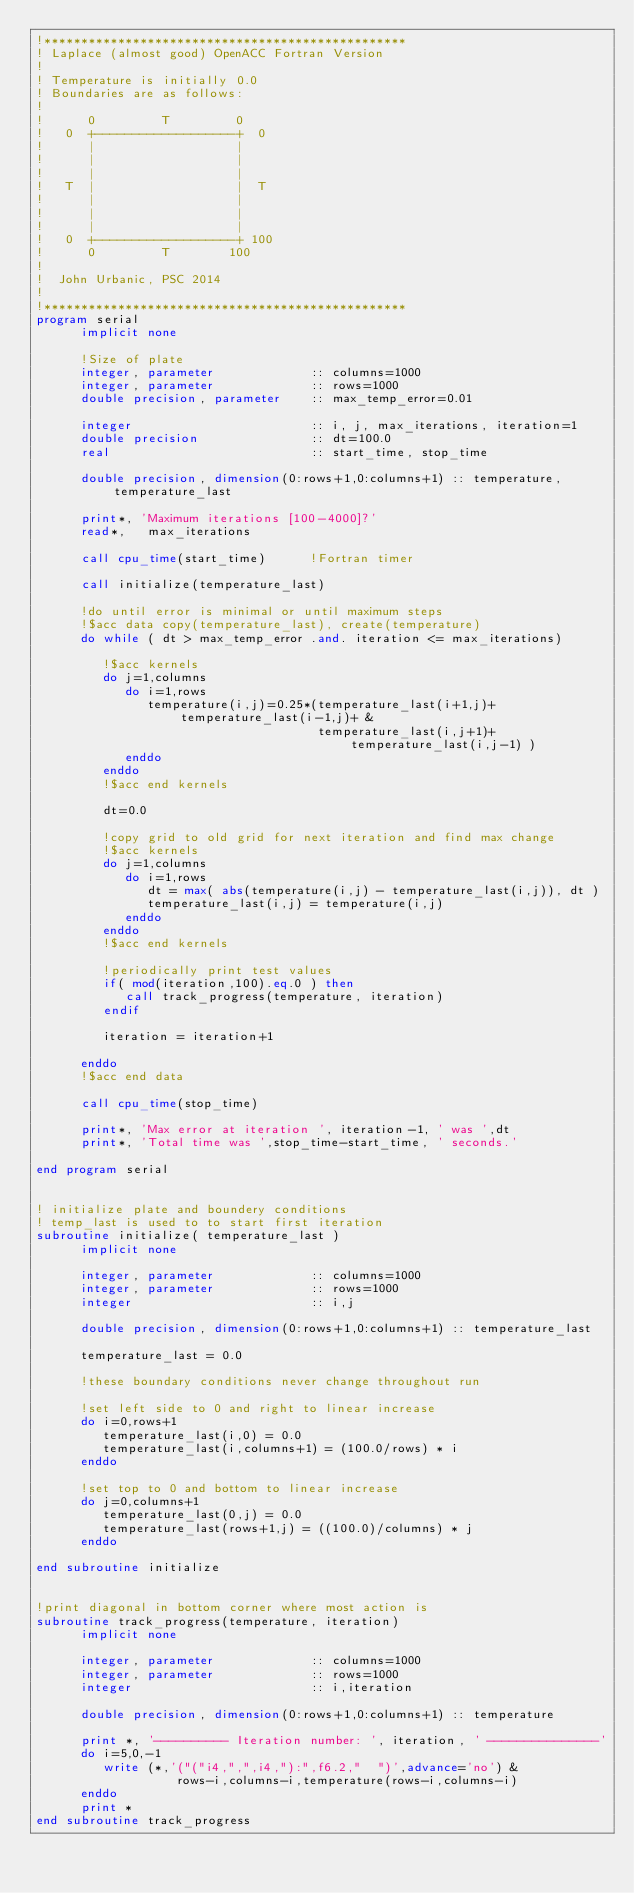<code> <loc_0><loc_0><loc_500><loc_500><_FORTRAN_>!*************************************************
! Laplace (almost good) OpenACC Fortran Version
!
! Temperature is initially 0.0
! Boundaries are as follows:
!
!      0         T         0
!   0  +-------------------+  0
!      |                   |
!      |                   |
!      |                   |
!   T  |                   |  T
!      |                   |
!      |                   |
!      |                   |
!   0  +-------------------+ 100
!      0         T        100
!
!  John Urbanic, PSC 2014
!
!*************************************************
program serial
      implicit none

      !Size of plate
      integer, parameter             :: columns=1000
      integer, parameter             :: rows=1000
      double precision, parameter    :: max_temp_error=0.01

      integer                        :: i, j, max_iterations, iteration=1
      double precision               :: dt=100.0
      real                           :: start_time, stop_time

      double precision, dimension(0:rows+1,0:columns+1) :: temperature, temperature_last

      print*, 'Maximum iterations [100-4000]?'
      read*,   max_iterations

      call cpu_time(start_time)      !Fortran timer

      call initialize(temperature_last)

      !do until error is minimal or until maximum steps
      !$acc data copy(temperature_last), create(temperature)
      do while ( dt > max_temp_error .and. iteration <= max_iterations)

         !$acc kernels
         do j=1,columns
            do i=1,rows
               temperature(i,j)=0.25*(temperature_last(i+1,j)+temperature_last(i-1,j)+ &
                                      temperature_last(i,j+1)+temperature_last(i,j-1) )
            enddo
         enddo
         !$acc end kernels

         dt=0.0

         !copy grid to old grid for next iteration and find max change
         !$acc kernels
         do j=1,columns
            do i=1,rows
               dt = max( abs(temperature(i,j) - temperature_last(i,j)), dt )
               temperature_last(i,j) = temperature(i,j)
            enddo
         enddo
         !$acc end kernels

         !periodically print test values
         if( mod(iteration,100).eq.0 ) then
            call track_progress(temperature, iteration)
         endif

         iteration = iteration+1

      enddo
      !$acc end data

      call cpu_time(stop_time)

      print*, 'Max error at iteration ', iteration-1, ' was ',dt
      print*, 'Total time was ',stop_time-start_time, ' seconds.'

end program serial


! initialize plate and boundery conditions
! temp_last is used to to start first iteration
subroutine initialize( temperature_last )
      implicit none

      integer, parameter             :: columns=1000
      integer, parameter             :: rows=1000
      integer                        :: i,j

      double precision, dimension(0:rows+1,0:columns+1) :: temperature_last

      temperature_last = 0.0

      !these boundary conditions never change throughout run

      !set left side to 0 and right to linear increase
      do i=0,rows+1
         temperature_last(i,0) = 0.0
         temperature_last(i,columns+1) = (100.0/rows) * i
      enddo

      !set top to 0 and bottom to linear increase
      do j=0,columns+1
         temperature_last(0,j) = 0.0
         temperature_last(rows+1,j) = ((100.0)/columns) * j
      enddo

end subroutine initialize


!print diagonal in bottom corner where most action is
subroutine track_progress(temperature, iteration)
      implicit none

      integer, parameter             :: columns=1000
      integer, parameter             :: rows=1000
      integer                        :: i,iteration

      double precision, dimension(0:rows+1,0:columns+1) :: temperature

      print *, '---------- Iteration number: ', iteration, ' ---------------'
      do i=5,0,-1
         write (*,'("("i4,",",i4,"):",f6.2,"  ")',advance='no') &
                   rows-i,columns-i,temperature(rows-i,columns-i)
      enddo
      print *
end subroutine track_progress
</code> 